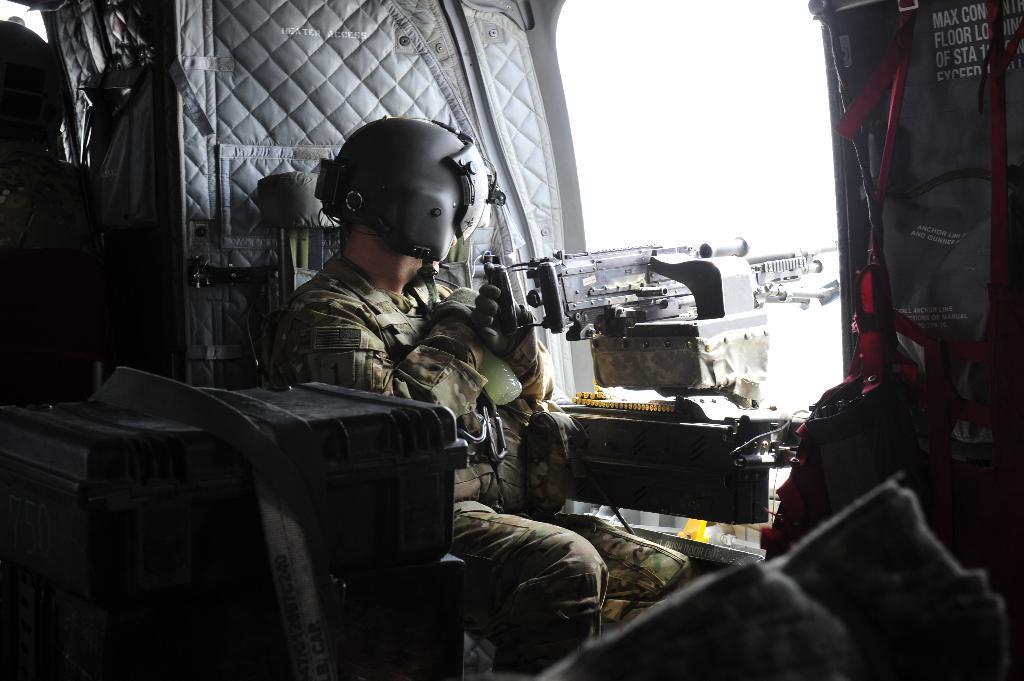Please provide a concise description of this image. In this picture we can see a army man who is wearing helmet, gloves, uniform and holding a bottle. Beside him we can see a machine gun. On the bottom left corner we can see black boxes. Here we can see some clothes. 